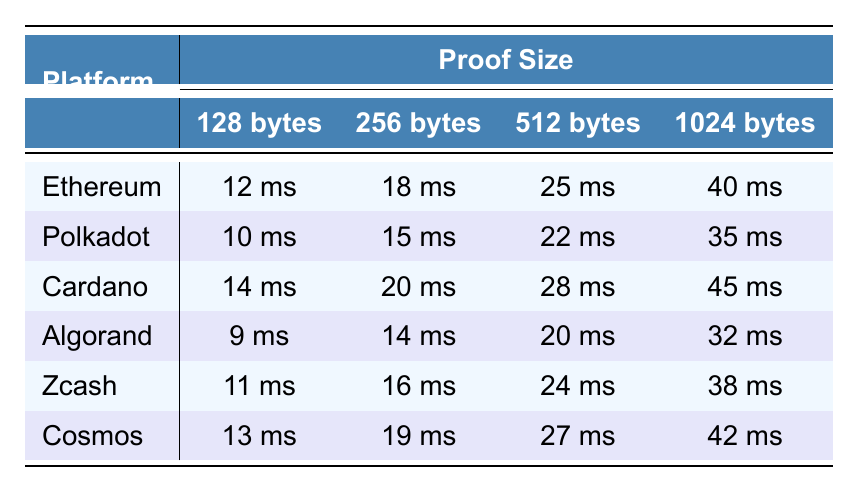What is the verification time for Zcash with a proof size of 512 bytes? Referring to the table, Zcash has a verification time of 24 ms for a proof size of 512 bytes.
Answer: 24 ms Which blockchain platform has the lowest verification time for a proof size of 128 bytes? The table shows that Algorand has the lowest verification time of 9 ms for a proof size of 128 bytes.
Answer: Algorand What is the verification time difference between Ethereum and Polkadot for a proof size of 1024 bytes? The verification time for Ethereum at 1024 bytes is 40 ms, and for Polkadot, it is 35 ms. The difference is 40 ms - 35 ms = 5 ms.
Answer: 5 ms What is the average verification time for all platforms with a proof size of 256 bytes? The verification times for 256 bytes are 18 ms (Ethereum), 15 ms (Polkadot), 20 ms (Cardano), 14 ms (Algorand), 16 ms (Zcash), and 19 ms (Cosmos). Adding these values gives 18 + 15 + 20 + 14 + 16 + 19 = 102 ms. The average is 102 ms / 6 = 17 ms.
Answer: 17 ms Is the verification time for Cardano greater than the average verification time for all platforms at a proof size of 1024 bytes? Cardano's verification time at 1024 bytes is 45 ms. The average for all platforms is (40+35+45+32+38+42)/6 = 39 ms. Since 45 ms > 39 ms, the answer is yes.
Answer: Yes Which blockchain platform has the highest verification time for a proof size of 128 bytes? Looking at the table, Cardano has the highest verification time of 14 ms for a proof size of 128 bytes.
Answer: Cardano What is the median verification time for a proof size of 512 bytes across all platforms? The verification times for 512 bytes are 25 ms (Ethereum), 22 ms (Polkadot), 28 ms (Cardano), 20 ms (Algorand), 24 ms (Zcash), and 27 ms (Cosmos). Arranging these values gives 20, 22, 24, 25, 27, 28. The median is (24 + 25) / 2 = 24.5 ms.
Answer: 24.5 ms Which proof size has the maximum verification time for the lowest platform? The lowest platform is Algorand, with the maximum verification time for the largest proof size of 1024 bytes, which is 32 ms.
Answer: 32 ms If we sum the verification times for all platforms at 128 bytes, what is the total? The verification times for 128 bytes are 12 ms (Ethereum), 10 ms (Polkadot), 14 ms (Cardano), 9 ms (Algorand), 11 ms (Zcash), and 13 ms (Cosmos). Adding them gives 12 + 10 + 14 + 9 + 11 + 13 = 69 ms.
Answer: 69 ms 